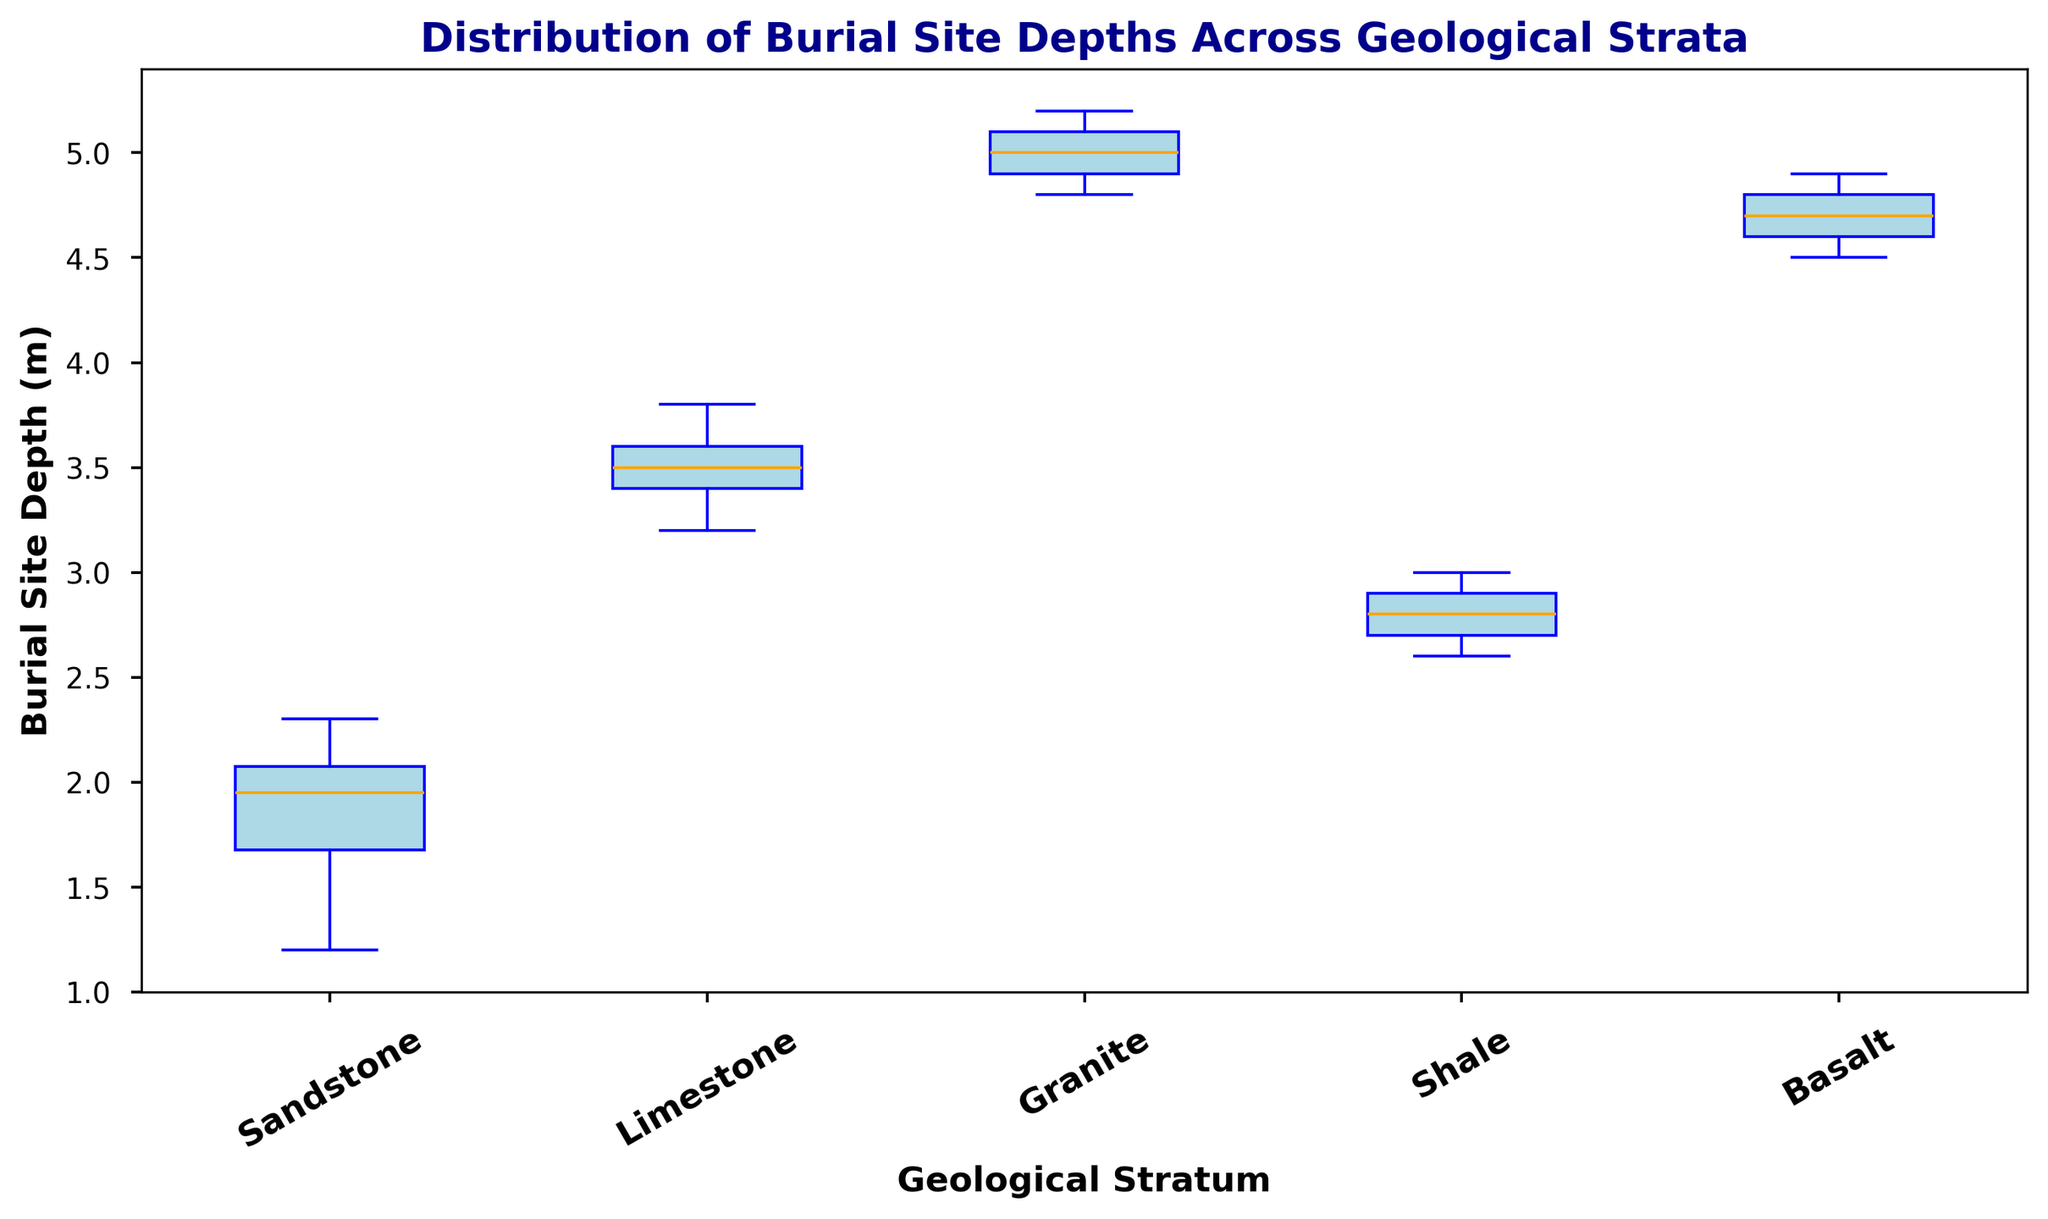What geological stratum has the deepest burial site depth median? To determine which geological stratum has the deepest burial site depth median, we need to look at the central horizontal lines inside the boxes. The box representing the Granite stratum has the highest median value.
Answer: Granite Which stratum has the most spread-out burial site depths? The spread of data can be determined by the length of the box and whiskers. By observing the box plots, the Granite stratum has the most extended range from the bottom to the top whisker, indicating the highest spread of burial site depths.
Answer: Granite Is the median burial depth in the Limestone stratum greater than the one in the Sandstone stratum? The central horizontal line in each box indicates the median. For Limestone, the median line is higher than that for Sandstone. This shows that the median depth for Limestone is greater.
Answer: Yes Which stratum has the least variability in burial site depths? Variability can be understood by looking at the range of the interquartile range (IQR), represented by the length of the box. The Sandstone stratum has the shortest box, indicating the least variability in burial site depths.
Answer: Sandstone Are the burial site depths in the Basalt stratum more spread out than those in the Shale stratum? To compare the spread, examine the length of the box and whiskers. The Basalt stratum has a slightly shorter overall range than the Shale stratum, indicating that Shale is more spread out in terms of burial site depths.
Answer: No What is the general trend in burial site depth distribution among the strata? Observing all boxes, there is a trend where deeper burial site depths are found in harder rock strata such as Granite and Basalt, while shallower depths are found in softer strata like Sandstone and Shale. This conclusion comes from the visual positions of the medians and the overall height of boxes.
Answer: Deeper in harder strata Which stratum's upper quartile (top edge of the box) is the highest? The top edge of the box represents the upper quartile for each stratum. The Granite stratum’s upper quartile is the highest among all strata, as its top edge is the highest on the plot.
Answer: Granite 